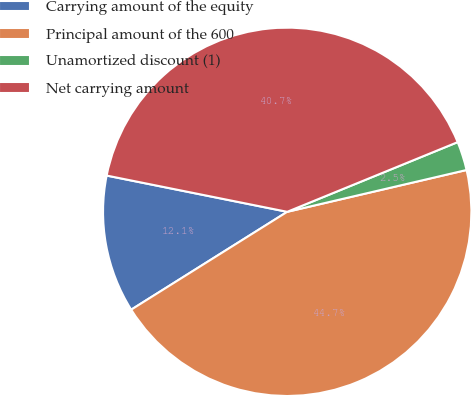<chart> <loc_0><loc_0><loc_500><loc_500><pie_chart><fcel>Carrying amount of the equity<fcel>Principal amount of the 600<fcel>Unamortized discount (1)<fcel>Net carrying amount<nl><fcel>12.07%<fcel>44.73%<fcel>2.53%<fcel>40.67%<nl></chart> 